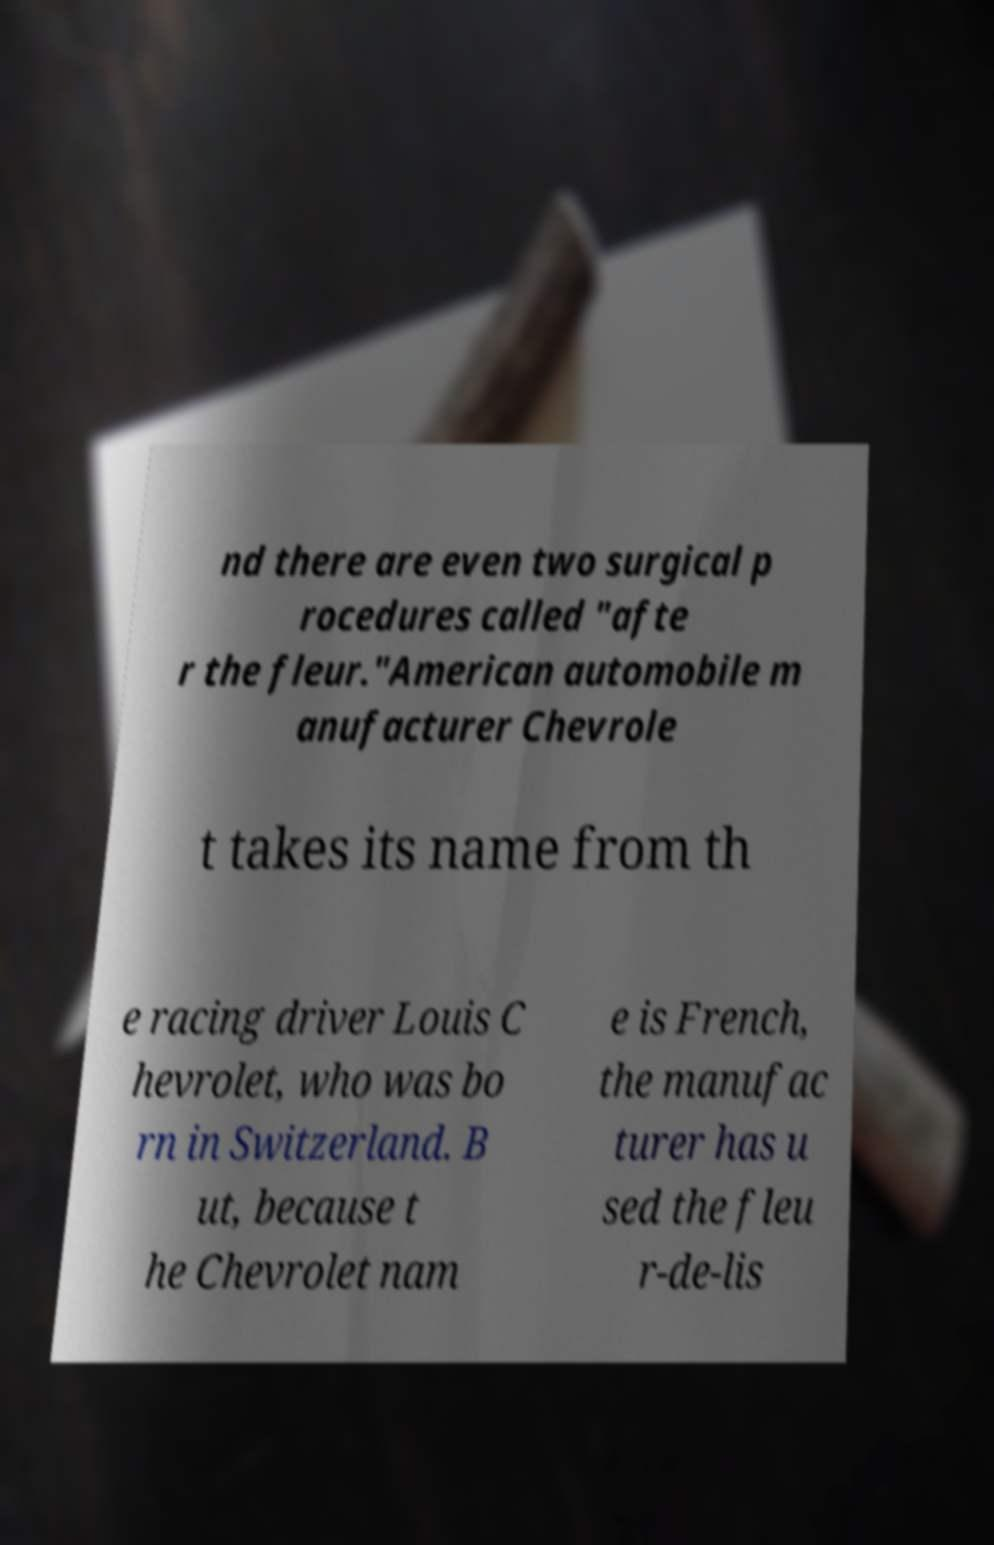Could you assist in decoding the text presented in this image and type it out clearly? nd there are even two surgical p rocedures called "afte r the fleur."American automobile m anufacturer Chevrole t takes its name from th e racing driver Louis C hevrolet, who was bo rn in Switzerland. B ut, because t he Chevrolet nam e is French, the manufac turer has u sed the fleu r-de-lis 